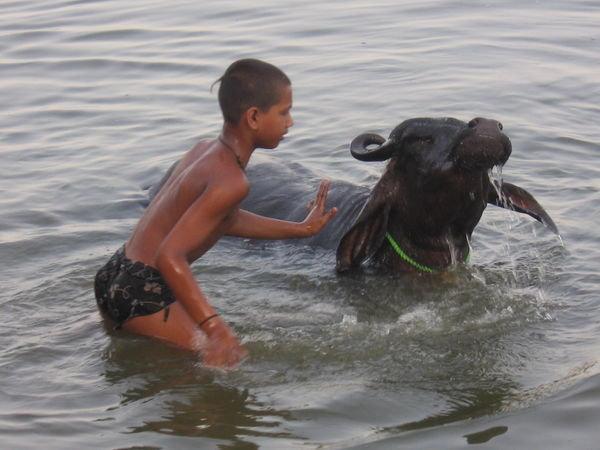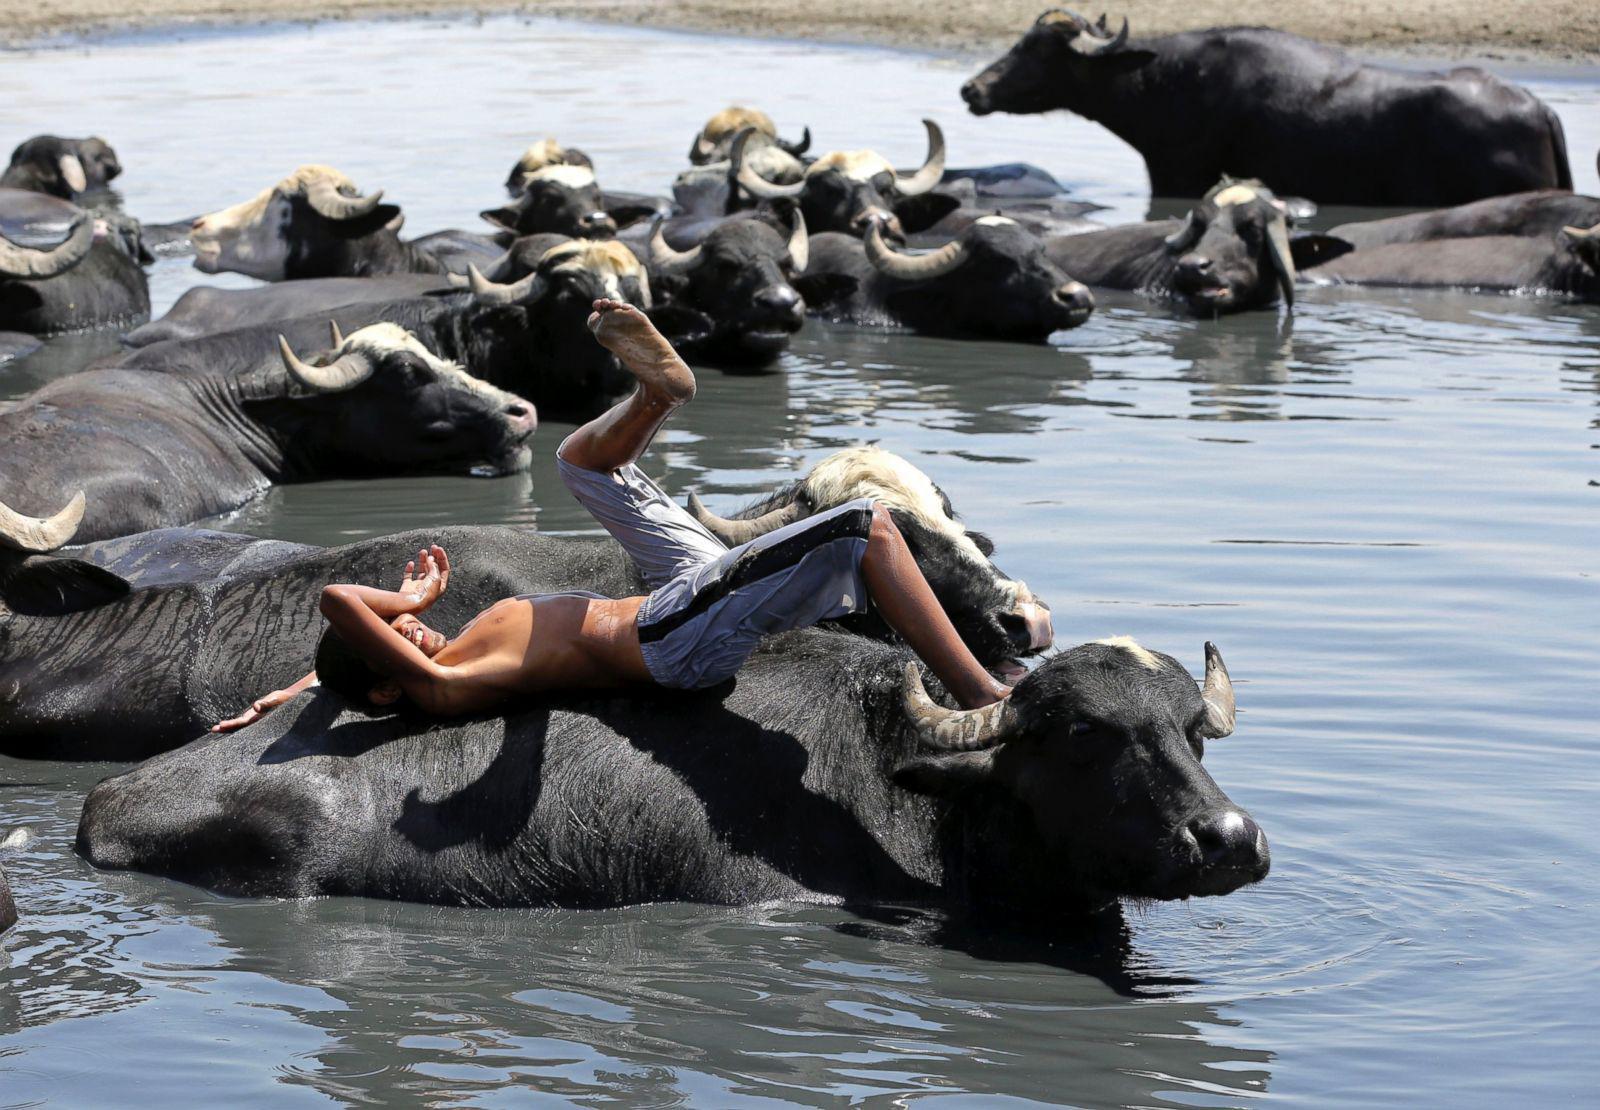The first image is the image on the left, the second image is the image on the right. Assess this claim about the two images: "The right image contains no more than one water buffalo.". Correct or not? Answer yes or no. No. The first image is the image on the left, the second image is the image on the right. Assess this claim about the two images: "One image shows a shirtless male standing in water and holding a hand toward a water buffalo in water to its neck.". Correct or not? Answer yes or no. Yes. 